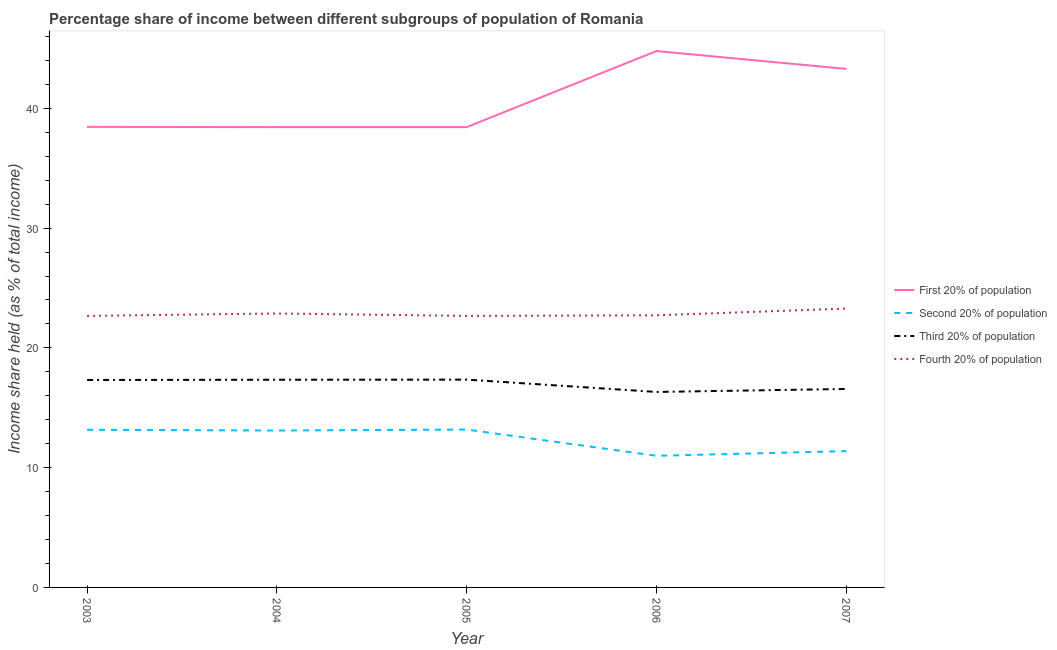Is the number of lines equal to the number of legend labels?
Keep it short and to the point. Yes. What is the share of the income held by second 20% of the population in 2005?
Offer a very short reply. 13.18. Across all years, what is the maximum share of the income held by second 20% of the population?
Your answer should be compact. 13.18. Across all years, what is the minimum share of the income held by fourth 20% of the population?
Offer a terse response. 22.67. In which year was the share of the income held by fourth 20% of the population minimum?
Your answer should be compact. 2003. What is the total share of the income held by first 20% of the population in the graph?
Give a very brief answer. 203.38. What is the difference between the share of the income held by second 20% of the population in 2003 and that in 2006?
Offer a terse response. 2.17. What is the difference between the share of the income held by first 20% of the population in 2007 and the share of the income held by fourth 20% of the population in 2003?
Offer a terse response. 20.62. What is the average share of the income held by second 20% of the population per year?
Make the answer very short. 12.36. In the year 2003, what is the difference between the share of the income held by third 20% of the population and share of the income held by first 20% of the population?
Keep it short and to the point. -21.13. What is the ratio of the share of the income held by second 20% of the population in 2004 to that in 2007?
Your response must be concise. 1.15. Is the share of the income held by fourth 20% of the population in 2003 less than that in 2005?
Your answer should be very brief. No. What is the difference between the highest and the second highest share of the income held by second 20% of the population?
Give a very brief answer. 0.02. What is the difference between the highest and the lowest share of the income held by first 20% of the population?
Give a very brief answer. 6.35. Is it the case that in every year, the sum of the share of the income held by first 20% of the population and share of the income held by fourth 20% of the population is greater than the sum of share of the income held by second 20% of the population and share of the income held by third 20% of the population?
Provide a succinct answer. Yes. Is the share of the income held by second 20% of the population strictly less than the share of the income held by third 20% of the population over the years?
Your answer should be compact. Yes. How many lines are there?
Make the answer very short. 4. Does the graph contain any zero values?
Provide a short and direct response. No. Does the graph contain grids?
Your answer should be compact. No. How many legend labels are there?
Your answer should be compact. 4. What is the title of the graph?
Ensure brevity in your answer.  Percentage share of income between different subgroups of population of Romania. Does "Korea" appear as one of the legend labels in the graph?
Your response must be concise. No. What is the label or title of the Y-axis?
Keep it short and to the point. Income share held (as % of total income). What is the Income share held (as % of total income) in First 20% of population in 2003?
Offer a very short reply. 38.45. What is the Income share held (as % of total income) in Second 20% of population in 2003?
Offer a very short reply. 13.16. What is the Income share held (as % of total income) in Third 20% of population in 2003?
Ensure brevity in your answer.  17.32. What is the Income share held (as % of total income) in Fourth 20% of population in 2003?
Keep it short and to the point. 22.67. What is the Income share held (as % of total income) of First 20% of population in 2004?
Your response must be concise. 38.43. What is the Income share held (as % of total income) of Second 20% of population in 2004?
Offer a terse response. 13.1. What is the Income share held (as % of total income) in Third 20% of population in 2004?
Your answer should be very brief. 17.34. What is the Income share held (as % of total income) of Fourth 20% of population in 2004?
Your response must be concise. 22.87. What is the Income share held (as % of total income) of First 20% of population in 2005?
Provide a succinct answer. 38.43. What is the Income share held (as % of total income) in Second 20% of population in 2005?
Provide a succinct answer. 13.18. What is the Income share held (as % of total income) in Third 20% of population in 2005?
Your answer should be compact. 17.35. What is the Income share held (as % of total income) of Fourth 20% of population in 2005?
Make the answer very short. 22.67. What is the Income share held (as % of total income) in First 20% of population in 2006?
Your answer should be compact. 44.78. What is the Income share held (as % of total income) in Second 20% of population in 2006?
Give a very brief answer. 10.99. What is the Income share held (as % of total income) of Third 20% of population in 2006?
Make the answer very short. 16.32. What is the Income share held (as % of total income) in Fourth 20% of population in 2006?
Ensure brevity in your answer.  22.72. What is the Income share held (as % of total income) of First 20% of population in 2007?
Your response must be concise. 43.29. What is the Income share held (as % of total income) in Second 20% of population in 2007?
Give a very brief answer. 11.38. What is the Income share held (as % of total income) of Third 20% of population in 2007?
Your answer should be compact. 16.57. What is the Income share held (as % of total income) in Fourth 20% of population in 2007?
Give a very brief answer. 23.28. Across all years, what is the maximum Income share held (as % of total income) in First 20% of population?
Provide a short and direct response. 44.78. Across all years, what is the maximum Income share held (as % of total income) in Second 20% of population?
Ensure brevity in your answer.  13.18. Across all years, what is the maximum Income share held (as % of total income) of Third 20% of population?
Your answer should be very brief. 17.35. Across all years, what is the maximum Income share held (as % of total income) of Fourth 20% of population?
Your answer should be compact. 23.28. Across all years, what is the minimum Income share held (as % of total income) in First 20% of population?
Your answer should be very brief. 38.43. Across all years, what is the minimum Income share held (as % of total income) in Second 20% of population?
Your answer should be compact. 10.99. Across all years, what is the minimum Income share held (as % of total income) of Third 20% of population?
Your response must be concise. 16.32. Across all years, what is the minimum Income share held (as % of total income) in Fourth 20% of population?
Provide a succinct answer. 22.67. What is the total Income share held (as % of total income) of First 20% of population in the graph?
Provide a succinct answer. 203.38. What is the total Income share held (as % of total income) of Second 20% of population in the graph?
Give a very brief answer. 61.81. What is the total Income share held (as % of total income) of Third 20% of population in the graph?
Provide a short and direct response. 84.9. What is the total Income share held (as % of total income) of Fourth 20% of population in the graph?
Provide a short and direct response. 114.21. What is the difference between the Income share held (as % of total income) in First 20% of population in 2003 and that in 2004?
Offer a very short reply. 0.02. What is the difference between the Income share held (as % of total income) of Second 20% of population in 2003 and that in 2004?
Keep it short and to the point. 0.06. What is the difference between the Income share held (as % of total income) in Third 20% of population in 2003 and that in 2004?
Your answer should be compact. -0.02. What is the difference between the Income share held (as % of total income) of Second 20% of population in 2003 and that in 2005?
Provide a succinct answer. -0.02. What is the difference between the Income share held (as % of total income) in Third 20% of population in 2003 and that in 2005?
Give a very brief answer. -0.03. What is the difference between the Income share held (as % of total income) of Fourth 20% of population in 2003 and that in 2005?
Your answer should be compact. 0. What is the difference between the Income share held (as % of total income) of First 20% of population in 2003 and that in 2006?
Ensure brevity in your answer.  -6.33. What is the difference between the Income share held (as % of total income) of Second 20% of population in 2003 and that in 2006?
Your response must be concise. 2.17. What is the difference between the Income share held (as % of total income) of Fourth 20% of population in 2003 and that in 2006?
Provide a succinct answer. -0.05. What is the difference between the Income share held (as % of total income) in First 20% of population in 2003 and that in 2007?
Your response must be concise. -4.84. What is the difference between the Income share held (as % of total income) in Second 20% of population in 2003 and that in 2007?
Your response must be concise. 1.78. What is the difference between the Income share held (as % of total income) of Fourth 20% of population in 2003 and that in 2007?
Your response must be concise. -0.61. What is the difference between the Income share held (as % of total income) of First 20% of population in 2004 and that in 2005?
Make the answer very short. 0. What is the difference between the Income share held (as % of total income) in Second 20% of population in 2004 and that in 2005?
Provide a succinct answer. -0.08. What is the difference between the Income share held (as % of total income) of Third 20% of population in 2004 and that in 2005?
Your answer should be compact. -0.01. What is the difference between the Income share held (as % of total income) of First 20% of population in 2004 and that in 2006?
Your response must be concise. -6.35. What is the difference between the Income share held (as % of total income) of Second 20% of population in 2004 and that in 2006?
Keep it short and to the point. 2.11. What is the difference between the Income share held (as % of total income) of First 20% of population in 2004 and that in 2007?
Your answer should be very brief. -4.86. What is the difference between the Income share held (as % of total income) in Second 20% of population in 2004 and that in 2007?
Your response must be concise. 1.72. What is the difference between the Income share held (as % of total income) of Third 20% of population in 2004 and that in 2007?
Your answer should be compact. 0.77. What is the difference between the Income share held (as % of total income) of Fourth 20% of population in 2004 and that in 2007?
Your answer should be very brief. -0.41. What is the difference between the Income share held (as % of total income) of First 20% of population in 2005 and that in 2006?
Make the answer very short. -6.35. What is the difference between the Income share held (as % of total income) in Second 20% of population in 2005 and that in 2006?
Your answer should be compact. 2.19. What is the difference between the Income share held (as % of total income) in Third 20% of population in 2005 and that in 2006?
Ensure brevity in your answer.  1.03. What is the difference between the Income share held (as % of total income) of Fourth 20% of population in 2005 and that in 2006?
Your answer should be very brief. -0.05. What is the difference between the Income share held (as % of total income) in First 20% of population in 2005 and that in 2007?
Your answer should be compact. -4.86. What is the difference between the Income share held (as % of total income) in Third 20% of population in 2005 and that in 2007?
Provide a short and direct response. 0.78. What is the difference between the Income share held (as % of total income) in Fourth 20% of population in 2005 and that in 2007?
Keep it short and to the point. -0.61. What is the difference between the Income share held (as % of total income) of First 20% of population in 2006 and that in 2007?
Make the answer very short. 1.49. What is the difference between the Income share held (as % of total income) of Second 20% of population in 2006 and that in 2007?
Keep it short and to the point. -0.39. What is the difference between the Income share held (as % of total income) of Fourth 20% of population in 2006 and that in 2007?
Keep it short and to the point. -0.56. What is the difference between the Income share held (as % of total income) of First 20% of population in 2003 and the Income share held (as % of total income) of Second 20% of population in 2004?
Offer a very short reply. 25.35. What is the difference between the Income share held (as % of total income) in First 20% of population in 2003 and the Income share held (as % of total income) in Third 20% of population in 2004?
Ensure brevity in your answer.  21.11. What is the difference between the Income share held (as % of total income) in First 20% of population in 2003 and the Income share held (as % of total income) in Fourth 20% of population in 2004?
Your response must be concise. 15.58. What is the difference between the Income share held (as % of total income) in Second 20% of population in 2003 and the Income share held (as % of total income) in Third 20% of population in 2004?
Keep it short and to the point. -4.18. What is the difference between the Income share held (as % of total income) of Second 20% of population in 2003 and the Income share held (as % of total income) of Fourth 20% of population in 2004?
Give a very brief answer. -9.71. What is the difference between the Income share held (as % of total income) in Third 20% of population in 2003 and the Income share held (as % of total income) in Fourth 20% of population in 2004?
Offer a very short reply. -5.55. What is the difference between the Income share held (as % of total income) in First 20% of population in 2003 and the Income share held (as % of total income) in Second 20% of population in 2005?
Your answer should be very brief. 25.27. What is the difference between the Income share held (as % of total income) of First 20% of population in 2003 and the Income share held (as % of total income) of Third 20% of population in 2005?
Your answer should be very brief. 21.1. What is the difference between the Income share held (as % of total income) of First 20% of population in 2003 and the Income share held (as % of total income) of Fourth 20% of population in 2005?
Your response must be concise. 15.78. What is the difference between the Income share held (as % of total income) in Second 20% of population in 2003 and the Income share held (as % of total income) in Third 20% of population in 2005?
Your answer should be compact. -4.19. What is the difference between the Income share held (as % of total income) of Second 20% of population in 2003 and the Income share held (as % of total income) of Fourth 20% of population in 2005?
Offer a terse response. -9.51. What is the difference between the Income share held (as % of total income) in Third 20% of population in 2003 and the Income share held (as % of total income) in Fourth 20% of population in 2005?
Your answer should be very brief. -5.35. What is the difference between the Income share held (as % of total income) of First 20% of population in 2003 and the Income share held (as % of total income) of Second 20% of population in 2006?
Give a very brief answer. 27.46. What is the difference between the Income share held (as % of total income) in First 20% of population in 2003 and the Income share held (as % of total income) in Third 20% of population in 2006?
Offer a terse response. 22.13. What is the difference between the Income share held (as % of total income) of First 20% of population in 2003 and the Income share held (as % of total income) of Fourth 20% of population in 2006?
Provide a succinct answer. 15.73. What is the difference between the Income share held (as % of total income) of Second 20% of population in 2003 and the Income share held (as % of total income) of Third 20% of population in 2006?
Your answer should be very brief. -3.16. What is the difference between the Income share held (as % of total income) in Second 20% of population in 2003 and the Income share held (as % of total income) in Fourth 20% of population in 2006?
Your response must be concise. -9.56. What is the difference between the Income share held (as % of total income) in Third 20% of population in 2003 and the Income share held (as % of total income) in Fourth 20% of population in 2006?
Ensure brevity in your answer.  -5.4. What is the difference between the Income share held (as % of total income) of First 20% of population in 2003 and the Income share held (as % of total income) of Second 20% of population in 2007?
Provide a succinct answer. 27.07. What is the difference between the Income share held (as % of total income) of First 20% of population in 2003 and the Income share held (as % of total income) of Third 20% of population in 2007?
Ensure brevity in your answer.  21.88. What is the difference between the Income share held (as % of total income) of First 20% of population in 2003 and the Income share held (as % of total income) of Fourth 20% of population in 2007?
Make the answer very short. 15.17. What is the difference between the Income share held (as % of total income) in Second 20% of population in 2003 and the Income share held (as % of total income) in Third 20% of population in 2007?
Give a very brief answer. -3.41. What is the difference between the Income share held (as % of total income) of Second 20% of population in 2003 and the Income share held (as % of total income) of Fourth 20% of population in 2007?
Give a very brief answer. -10.12. What is the difference between the Income share held (as % of total income) of Third 20% of population in 2003 and the Income share held (as % of total income) of Fourth 20% of population in 2007?
Keep it short and to the point. -5.96. What is the difference between the Income share held (as % of total income) of First 20% of population in 2004 and the Income share held (as % of total income) of Second 20% of population in 2005?
Keep it short and to the point. 25.25. What is the difference between the Income share held (as % of total income) of First 20% of population in 2004 and the Income share held (as % of total income) of Third 20% of population in 2005?
Provide a short and direct response. 21.08. What is the difference between the Income share held (as % of total income) of First 20% of population in 2004 and the Income share held (as % of total income) of Fourth 20% of population in 2005?
Keep it short and to the point. 15.76. What is the difference between the Income share held (as % of total income) in Second 20% of population in 2004 and the Income share held (as % of total income) in Third 20% of population in 2005?
Your response must be concise. -4.25. What is the difference between the Income share held (as % of total income) in Second 20% of population in 2004 and the Income share held (as % of total income) in Fourth 20% of population in 2005?
Provide a succinct answer. -9.57. What is the difference between the Income share held (as % of total income) of Third 20% of population in 2004 and the Income share held (as % of total income) of Fourth 20% of population in 2005?
Keep it short and to the point. -5.33. What is the difference between the Income share held (as % of total income) of First 20% of population in 2004 and the Income share held (as % of total income) of Second 20% of population in 2006?
Your answer should be very brief. 27.44. What is the difference between the Income share held (as % of total income) in First 20% of population in 2004 and the Income share held (as % of total income) in Third 20% of population in 2006?
Offer a terse response. 22.11. What is the difference between the Income share held (as % of total income) in First 20% of population in 2004 and the Income share held (as % of total income) in Fourth 20% of population in 2006?
Provide a succinct answer. 15.71. What is the difference between the Income share held (as % of total income) in Second 20% of population in 2004 and the Income share held (as % of total income) in Third 20% of population in 2006?
Ensure brevity in your answer.  -3.22. What is the difference between the Income share held (as % of total income) of Second 20% of population in 2004 and the Income share held (as % of total income) of Fourth 20% of population in 2006?
Provide a succinct answer. -9.62. What is the difference between the Income share held (as % of total income) of Third 20% of population in 2004 and the Income share held (as % of total income) of Fourth 20% of population in 2006?
Ensure brevity in your answer.  -5.38. What is the difference between the Income share held (as % of total income) in First 20% of population in 2004 and the Income share held (as % of total income) in Second 20% of population in 2007?
Offer a terse response. 27.05. What is the difference between the Income share held (as % of total income) in First 20% of population in 2004 and the Income share held (as % of total income) in Third 20% of population in 2007?
Your answer should be very brief. 21.86. What is the difference between the Income share held (as % of total income) in First 20% of population in 2004 and the Income share held (as % of total income) in Fourth 20% of population in 2007?
Your answer should be very brief. 15.15. What is the difference between the Income share held (as % of total income) in Second 20% of population in 2004 and the Income share held (as % of total income) in Third 20% of population in 2007?
Provide a short and direct response. -3.47. What is the difference between the Income share held (as % of total income) of Second 20% of population in 2004 and the Income share held (as % of total income) of Fourth 20% of population in 2007?
Offer a terse response. -10.18. What is the difference between the Income share held (as % of total income) of Third 20% of population in 2004 and the Income share held (as % of total income) of Fourth 20% of population in 2007?
Give a very brief answer. -5.94. What is the difference between the Income share held (as % of total income) in First 20% of population in 2005 and the Income share held (as % of total income) in Second 20% of population in 2006?
Your answer should be very brief. 27.44. What is the difference between the Income share held (as % of total income) of First 20% of population in 2005 and the Income share held (as % of total income) of Third 20% of population in 2006?
Offer a terse response. 22.11. What is the difference between the Income share held (as % of total income) of First 20% of population in 2005 and the Income share held (as % of total income) of Fourth 20% of population in 2006?
Keep it short and to the point. 15.71. What is the difference between the Income share held (as % of total income) in Second 20% of population in 2005 and the Income share held (as % of total income) in Third 20% of population in 2006?
Provide a succinct answer. -3.14. What is the difference between the Income share held (as % of total income) of Second 20% of population in 2005 and the Income share held (as % of total income) of Fourth 20% of population in 2006?
Your answer should be compact. -9.54. What is the difference between the Income share held (as % of total income) of Third 20% of population in 2005 and the Income share held (as % of total income) of Fourth 20% of population in 2006?
Your response must be concise. -5.37. What is the difference between the Income share held (as % of total income) in First 20% of population in 2005 and the Income share held (as % of total income) in Second 20% of population in 2007?
Ensure brevity in your answer.  27.05. What is the difference between the Income share held (as % of total income) in First 20% of population in 2005 and the Income share held (as % of total income) in Third 20% of population in 2007?
Your response must be concise. 21.86. What is the difference between the Income share held (as % of total income) of First 20% of population in 2005 and the Income share held (as % of total income) of Fourth 20% of population in 2007?
Ensure brevity in your answer.  15.15. What is the difference between the Income share held (as % of total income) of Second 20% of population in 2005 and the Income share held (as % of total income) of Third 20% of population in 2007?
Give a very brief answer. -3.39. What is the difference between the Income share held (as % of total income) in Second 20% of population in 2005 and the Income share held (as % of total income) in Fourth 20% of population in 2007?
Provide a short and direct response. -10.1. What is the difference between the Income share held (as % of total income) in Third 20% of population in 2005 and the Income share held (as % of total income) in Fourth 20% of population in 2007?
Your answer should be compact. -5.93. What is the difference between the Income share held (as % of total income) in First 20% of population in 2006 and the Income share held (as % of total income) in Second 20% of population in 2007?
Your answer should be very brief. 33.4. What is the difference between the Income share held (as % of total income) of First 20% of population in 2006 and the Income share held (as % of total income) of Third 20% of population in 2007?
Your answer should be very brief. 28.21. What is the difference between the Income share held (as % of total income) of Second 20% of population in 2006 and the Income share held (as % of total income) of Third 20% of population in 2007?
Your answer should be compact. -5.58. What is the difference between the Income share held (as % of total income) of Second 20% of population in 2006 and the Income share held (as % of total income) of Fourth 20% of population in 2007?
Make the answer very short. -12.29. What is the difference between the Income share held (as % of total income) of Third 20% of population in 2006 and the Income share held (as % of total income) of Fourth 20% of population in 2007?
Offer a terse response. -6.96. What is the average Income share held (as % of total income) in First 20% of population per year?
Keep it short and to the point. 40.68. What is the average Income share held (as % of total income) of Second 20% of population per year?
Keep it short and to the point. 12.36. What is the average Income share held (as % of total income) in Third 20% of population per year?
Provide a short and direct response. 16.98. What is the average Income share held (as % of total income) of Fourth 20% of population per year?
Your answer should be very brief. 22.84. In the year 2003, what is the difference between the Income share held (as % of total income) of First 20% of population and Income share held (as % of total income) of Second 20% of population?
Keep it short and to the point. 25.29. In the year 2003, what is the difference between the Income share held (as % of total income) in First 20% of population and Income share held (as % of total income) in Third 20% of population?
Make the answer very short. 21.13. In the year 2003, what is the difference between the Income share held (as % of total income) in First 20% of population and Income share held (as % of total income) in Fourth 20% of population?
Give a very brief answer. 15.78. In the year 2003, what is the difference between the Income share held (as % of total income) of Second 20% of population and Income share held (as % of total income) of Third 20% of population?
Your answer should be very brief. -4.16. In the year 2003, what is the difference between the Income share held (as % of total income) of Second 20% of population and Income share held (as % of total income) of Fourth 20% of population?
Provide a short and direct response. -9.51. In the year 2003, what is the difference between the Income share held (as % of total income) of Third 20% of population and Income share held (as % of total income) of Fourth 20% of population?
Offer a terse response. -5.35. In the year 2004, what is the difference between the Income share held (as % of total income) in First 20% of population and Income share held (as % of total income) in Second 20% of population?
Give a very brief answer. 25.33. In the year 2004, what is the difference between the Income share held (as % of total income) in First 20% of population and Income share held (as % of total income) in Third 20% of population?
Your response must be concise. 21.09. In the year 2004, what is the difference between the Income share held (as % of total income) of First 20% of population and Income share held (as % of total income) of Fourth 20% of population?
Your answer should be very brief. 15.56. In the year 2004, what is the difference between the Income share held (as % of total income) in Second 20% of population and Income share held (as % of total income) in Third 20% of population?
Your answer should be compact. -4.24. In the year 2004, what is the difference between the Income share held (as % of total income) of Second 20% of population and Income share held (as % of total income) of Fourth 20% of population?
Your answer should be compact. -9.77. In the year 2004, what is the difference between the Income share held (as % of total income) of Third 20% of population and Income share held (as % of total income) of Fourth 20% of population?
Your answer should be very brief. -5.53. In the year 2005, what is the difference between the Income share held (as % of total income) in First 20% of population and Income share held (as % of total income) in Second 20% of population?
Provide a short and direct response. 25.25. In the year 2005, what is the difference between the Income share held (as % of total income) in First 20% of population and Income share held (as % of total income) in Third 20% of population?
Offer a very short reply. 21.08. In the year 2005, what is the difference between the Income share held (as % of total income) of First 20% of population and Income share held (as % of total income) of Fourth 20% of population?
Offer a terse response. 15.76. In the year 2005, what is the difference between the Income share held (as % of total income) of Second 20% of population and Income share held (as % of total income) of Third 20% of population?
Give a very brief answer. -4.17. In the year 2005, what is the difference between the Income share held (as % of total income) in Second 20% of population and Income share held (as % of total income) in Fourth 20% of population?
Offer a very short reply. -9.49. In the year 2005, what is the difference between the Income share held (as % of total income) of Third 20% of population and Income share held (as % of total income) of Fourth 20% of population?
Your answer should be compact. -5.32. In the year 2006, what is the difference between the Income share held (as % of total income) of First 20% of population and Income share held (as % of total income) of Second 20% of population?
Your answer should be very brief. 33.79. In the year 2006, what is the difference between the Income share held (as % of total income) of First 20% of population and Income share held (as % of total income) of Third 20% of population?
Give a very brief answer. 28.46. In the year 2006, what is the difference between the Income share held (as % of total income) in First 20% of population and Income share held (as % of total income) in Fourth 20% of population?
Your response must be concise. 22.06. In the year 2006, what is the difference between the Income share held (as % of total income) of Second 20% of population and Income share held (as % of total income) of Third 20% of population?
Your answer should be compact. -5.33. In the year 2006, what is the difference between the Income share held (as % of total income) of Second 20% of population and Income share held (as % of total income) of Fourth 20% of population?
Your answer should be compact. -11.73. In the year 2007, what is the difference between the Income share held (as % of total income) in First 20% of population and Income share held (as % of total income) in Second 20% of population?
Provide a short and direct response. 31.91. In the year 2007, what is the difference between the Income share held (as % of total income) in First 20% of population and Income share held (as % of total income) in Third 20% of population?
Provide a succinct answer. 26.72. In the year 2007, what is the difference between the Income share held (as % of total income) in First 20% of population and Income share held (as % of total income) in Fourth 20% of population?
Provide a short and direct response. 20.01. In the year 2007, what is the difference between the Income share held (as % of total income) of Second 20% of population and Income share held (as % of total income) of Third 20% of population?
Your answer should be compact. -5.19. In the year 2007, what is the difference between the Income share held (as % of total income) of Third 20% of population and Income share held (as % of total income) of Fourth 20% of population?
Give a very brief answer. -6.71. What is the ratio of the Income share held (as % of total income) of First 20% of population in 2003 to that in 2004?
Your answer should be very brief. 1. What is the ratio of the Income share held (as % of total income) of First 20% of population in 2003 to that in 2005?
Offer a very short reply. 1. What is the ratio of the Income share held (as % of total income) of Second 20% of population in 2003 to that in 2005?
Offer a terse response. 1. What is the ratio of the Income share held (as % of total income) in Third 20% of population in 2003 to that in 2005?
Ensure brevity in your answer.  1. What is the ratio of the Income share held (as % of total income) in Fourth 20% of population in 2003 to that in 2005?
Ensure brevity in your answer.  1. What is the ratio of the Income share held (as % of total income) of First 20% of population in 2003 to that in 2006?
Your response must be concise. 0.86. What is the ratio of the Income share held (as % of total income) of Second 20% of population in 2003 to that in 2006?
Ensure brevity in your answer.  1.2. What is the ratio of the Income share held (as % of total income) of Third 20% of population in 2003 to that in 2006?
Your answer should be very brief. 1.06. What is the ratio of the Income share held (as % of total income) of Fourth 20% of population in 2003 to that in 2006?
Your response must be concise. 1. What is the ratio of the Income share held (as % of total income) of First 20% of population in 2003 to that in 2007?
Offer a terse response. 0.89. What is the ratio of the Income share held (as % of total income) in Second 20% of population in 2003 to that in 2007?
Make the answer very short. 1.16. What is the ratio of the Income share held (as % of total income) of Third 20% of population in 2003 to that in 2007?
Your answer should be compact. 1.05. What is the ratio of the Income share held (as % of total income) of Fourth 20% of population in 2003 to that in 2007?
Provide a succinct answer. 0.97. What is the ratio of the Income share held (as % of total income) of Third 20% of population in 2004 to that in 2005?
Your response must be concise. 1. What is the ratio of the Income share held (as % of total income) of Fourth 20% of population in 2004 to that in 2005?
Your response must be concise. 1.01. What is the ratio of the Income share held (as % of total income) of First 20% of population in 2004 to that in 2006?
Offer a very short reply. 0.86. What is the ratio of the Income share held (as % of total income) of Second 20% of population in 2004 to that in 2006?
Offer a very short reply. 1.19. What is the ratio of the Income share held (as % of total income) of Third 20% of population in 2004 to that in 2006?
Provide a short and direct response. 1.06. What is the ratio of the Income share held (as % of total income) of Fourth 20% of population in 2004 to that in 2006?
Give a very brief answer. 1.01. What is the ratio of the Income share held (as % of total income) of First 20% of population in 2004 to that in 2007?
Your answer should be very brief. 0.89. What is the ratio of the Income share held (as % of total income) in Second 20% of population in 2004 to that in 2007?
Ensure brevity in your answer.  1.15. What is the ratio of the Income share held (as % of total income) in Third 20% of population in 2004 to that in 2007?
Provide a succinct answer. 1.05. What is the ratio of the Income share held (as % of total income) of Fourth 20% of population in 2004 to that in 2007?
Your answer should be very brief. 0.98. What is the ratio of the Income share held (as % of total income) in First 20% of population in 2005 to that in 2006?
Keep it short and to the point. 0.86. What is the ratio of the Income share held (as % of total income) of Second 20% of population in 2005 to that in 2006?
Make the answer very short. 1.2. What is the ratio of the Income share held (as % of total income) in Third 20% of population in 2005 to that in 2006?
Offer a terse response. 1.06. What is the ratio of the Income share held (as % of total income) in Fourth 20% of population in 2005 to that in 2006?
Provide a short and direct response. 1. What is the ratio of the Income share held (as % of total income) in First 20% of population in 2005 to that in 2007?
Give a very brief answer. 0.89. What is the ratio of the Income share held (as % of total income) in Second 20% of population in 2005 to that in 2007?
Provide a succinct answer. 1.16. What is the ratio of the Income share held (as % of total income) in Third 20% of population in 2005 to that in 2007?
Ensure brevity in your answer.  1.05. What is the ratio of the Income share held (as % of total income) of Fourth 20% of population in 2005 to that in 2007?
Your answer should be very brief. 0.97. What is the ratio of the Income share held (as % of total income) of First 20% of population in 2006 to that in 2007?
Ensure brevity in your answer.  1.03. What is the ratio of the Income share held (as % of total income) of Second 20% of population in 2006 to that in 2007?
Keep it short and to the point. 0.97. What is the ratio of the Income share held (as % of total income) in Third 20% of population in 2006 to that in 2007?
Offer a very short reply. 0.98. What is the ratio of the Income share held (as % of total income) in Fourth 20% of population in 2006 to that in 2007?
Ensure brevity in your answer.  0.98. What is the difference between the highest and the second highest Income share held (as % of total income) of First 20% of population?
Your answer should be compact. 1.49. What is the difference between the highest and the second highest Income share held (as % of total income) in Third 20% of population?
Offer a very short reply. 0.01. What is the difference between the highest and the second highest Income share held (as % of total income) of Fourth 20% of population?
Ensure brevity in your answer.  0.41. What is the difference between the highest and the lowest Income share held (as % of total income) of First 20% of population?
Your response must be concise. 6.35. What is the difference between the highest and the lowest Income share held (as % of total income) of Second 20% of population?
Your answer should be compact. 2.19. What is the difference between the highest and the lowest Income share held (as % of total income) in Third 20% of population?
Provide a succinct answer. 1.03. What is the difference between the highest and the lowest Income share held (as % of total income) in Fourth 20% of population?
Your answer should be compact. 0.61. 